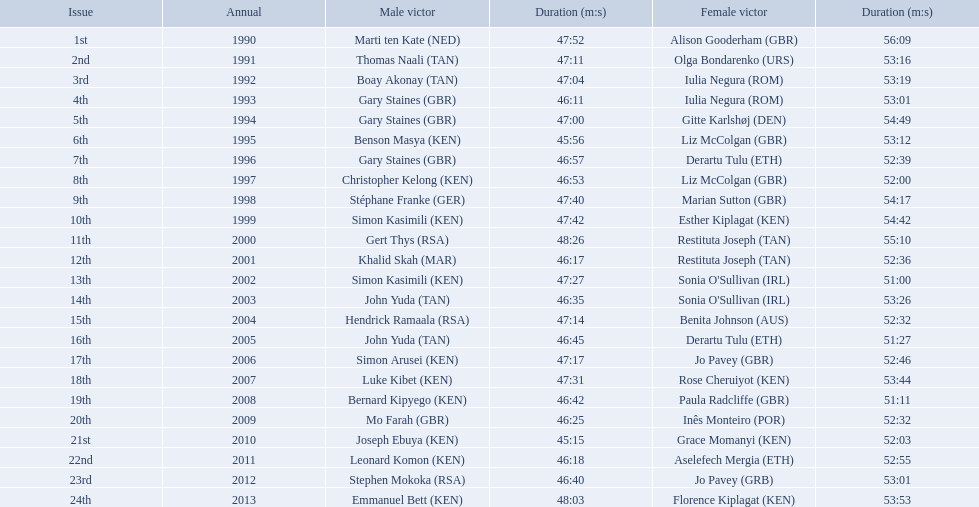Which of the runner in the great south run were women? Alison Gooderham (GBR), Olga Bondarenko (URS), Iulia Negura (ROM), Iulia Negura (ROM), Gitte Karlshøj (DEN), Liz McColgan (GBR), Derartu Tulu (ETH), Liz McColgan (GBR), Marian Sutton (GBR), Esther Kiplagat (KEN), Restituta Joseph (TAN), Restituta Joseph (TAN), Sonia O'Sullivan (IRL), Sonia O'Sullivan (IRL), Benita Johnson (AUS), Derartu Tulu (ETH), Jo Pavey (GBR), Rose Cheruiyot (KEN), Paula Radcliffe (GBR), Inês Monteiro (POR), Grace Momanyi (KEN), Aselefech Mergia (ETH), Jo Pavey (GRB), Florence Kiplagat (KEN). Of those women, which ones had a time of at least 53 minutes? Alison Gooderham (GBR), Olga Bondarenko (URS), Iulia Negura (ROM), Iulia Negura (ROM), Gitte Karlshøj (DEN), Liz McColgan (GBR), Marian Sutton (GBR), Esther Kiplagat (KEN), Restituta Joseph (TAN), Sonia O'Sullivan (IRL), Rose Cheruiyot (KEN), Jo Pavey (GRB), Florence Kiplagat (KEN). Between those women, which ones did not go over 53 minutes? Olga Bondarenko (URS), Iulia Negura (ROM), Iulia Negura (ROM), Liz McColgan (GBR), Sonia O'Sullivan (IRL), Rose Cheruiyot (KEN), Jo Pavey (GRB), Florence Kiplagat (KEN). Of those 8, what were the three slowest times? Sonia O'Sullivan (IRL), Rose Cheruiyot (KEN), Florence Kiplagat (KEN). Between only those 3 women, which runner had the fastest time? Sonia O'Sullivan (IRL). What was this women's time? 53:26. Which runners are from kenya? (ken) Benson Masya (KEN), Christopher Kelong (KEN), Simon Kasimili (KEN), Simon Kasimili (KEN), Simon Arusei (KEN), Luke Kibet (KEN), Bernard Kipyego (KEN), Joseph Ebuya (KEN), Leonard Komon (KEN), Emmanuel Bett (KEN). Of these, which times are under 46 minutes? Benson Masya (KEN), Joseph Ebuya (KEN). Which of these runners had the faster time? Joseph Ebuya (KEN). What are the names of each male winner? Marti ten Kate (NED), Thomas Naali (TAN), Boay Akonay (TAN), Gary Staines (GBR), Gary Staines (GBR), Benson Masya (KEN), Gary Staines (GBR), Christopher Kelong (KEN), Stéphane Franke (GER), Simon Kasimili (KEN), Gert Thys (RSA), Khalid Skah (MAR), Simon Kasimili (KEN), John Yuda (TAN), Hendrick Ramaala (RSA), John Yuda (TAN), Simon Arusei (KEN), Luke Kibet (KEN), Bernard Kipyego (KEN), Mo Farah (GBR), Joseph Ebuya (KEN), Leonard Komon (KEN), Stephen Mokoka (RSA), Emmanuel Bett (KEN). When did they race? 1990, 1991, 1992, 1993, 1994, 1995, 1996, 1997, 1998, 1999, 2000, 2001, 2002, 2003, 2004, 2005, 2006, 2007, 2008, 2009, 2010, 2011, 2012, 2013. Give me the full table as a dictionary. {'header': ['Issue', 'Annual', 'Male victor', 'Duration (m:s)', 'Female victor', 'Duration (m:s)'], 'rows': [['1st', '1990', 'Marti ten Kate\xa0(NED)', '47:52', 'Alison Gooderham\xa0(GBR)', '56:09'], ['2nd', '1991', 'Thomas Naali\xa0(TAN)', '47:11', 'Olga Bondarenko\xa0(URS)', '53:16'], ['3rd', '1992', 'Boay Akonay\xa0(TAN)', '47:04', 'Iulia Negura\xa0(ROM)', '53:19'], ['4th', '1993', 'Gary Staines\xa0(GBR)', '46:11', 'Iulia Negura\xa0(ROM)', '53:01'], ['5th', '1994', 'Gary Staines\xa0(GBR)', '47:00', 'Gitte Karlshøj\xa0(DEN)', '54:49'], ['6th', '1995', 'Benson Masya\xa0(KEN)', '45:56', 'Liz McColgan\xa0(GBR)', '53:12'], ['7th', '1996', 'Gary Staines\xa0(GBR)', '46:57', 'Derartu Tulu\xa0(ETH)', '52:39'], ['8th', '1997', 'Christopher Kelong\xa0(KEN)', '46:53', 'Liz McColgan\xa0(GBR)', '52:00'], ['9th', '1998', 'Stéphane Franke\xa0(GER)', '47:40', 'Marian Sutton\xa0(GBR)', '54:17'], ['10th', '1999', 'Simon Kasimili\xa0(KEN)', '47:42', 'Esther Kiplagat\xa0(KEN)', '54:42'], ['11th', '2000', 'Gert Thys\xa0(RSA)', '48:26', 'Restituta Joseph\xa0(TAN)', '55:10'], ['12th', '2001', 'Khalid Skah\xa0(MAR)', '46:17', 'Restituta Joseph\xa0(TAN)', '52:36'], ['13th', '2002', 'Simon Kasimili\xa0(KEN)', '47:27', "Sonia O'Sullivan\xa0(IRL)", '51:00'], ['14th', '2003', 'John Yuda\xa0(TAN)', '46:35', "Sonia O'Sullivan\xa0(IRL)", '53:26'], ['15th', '2004', 'Hendrick Ramaala\xa0(RSA)', '47:14', 'Benita Johnson\xa0(AUS)', '52:32'], ['16th', '2005', 'John Yuda\xa0(TAN)', '46:45', 'Derartu Tulu\xa0(ETH)', '51:27'], ['17th', '2006', 'Simon Arusei\xa0(KEN)', '47:17', 'Jo Pavey\xa0(GBR)', '52:46'], ['18th', '2007', 'Luke Kibet\xa0(KEN)', '47:31', 'Rose Cheruiyot\xa0(KEN)', '53:44'], ['19th', '2008', 'Bernard Kipyego\xa0(KEN)', '46:42', 'Paula Radcliffe\xa0(GBR)', '51:11'], ['20th', '2009', 'Mo Farah\xa0(GBR)', '46:25', 'Inês Monteiro\xa0(POR)', '52:32'], ['21st', '2010', 'Joseph Ebuya\xa0(KEN)', '45:15', 'Grace Momanyi\xa0(KEN)', '52:03'], ['22nd', '2011', 'Leonard Komon\xa0(KEN)', '46:18', 'Aselefech Mergia\xa0(ETH)', '52:55'], ['23rd', '2012', 'Stephen Mokoka\xa0(RSA)', '46:40', 'Jo Pavey\xa0(GRB)', '53:01'], ['24th', '2013', 'Emmanuel Bett\xa0(KEN)', '48:03', 'Florence Kiplagat\xa0(KEN)', '53:53']]} And what were their times? 47:52, 47:11, 47:04, 46:11, 47:00, 45:56, 46:57, 46:53, 47:40, 47:42, 48:26, 46:17, 47:27, 46:35, 47:14, 46:45, 47:17, 47:31, 46:42, 46:25, 45:15, 46:18, 46:40, 48:03. Of those times, which athlete had the fastest time? Joseph Ebuya (KEN). 